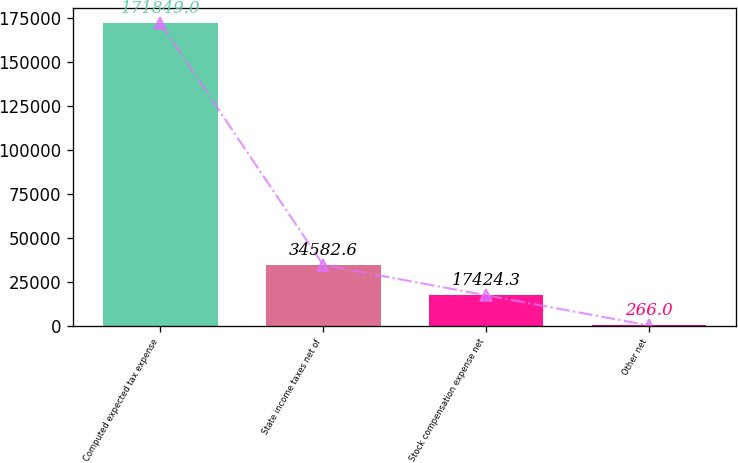<chart> <loc_0><loc_0><loc_500><loc_500><bar_chart><fcel>Computed expected tax expense<fcel>State income taxes net of<fcel>Stock compensation expense net<fcel>Other net<nl><fcel>171849<fcel>34582.6<fcel>17424.3<fcel>266<nl></chart> 